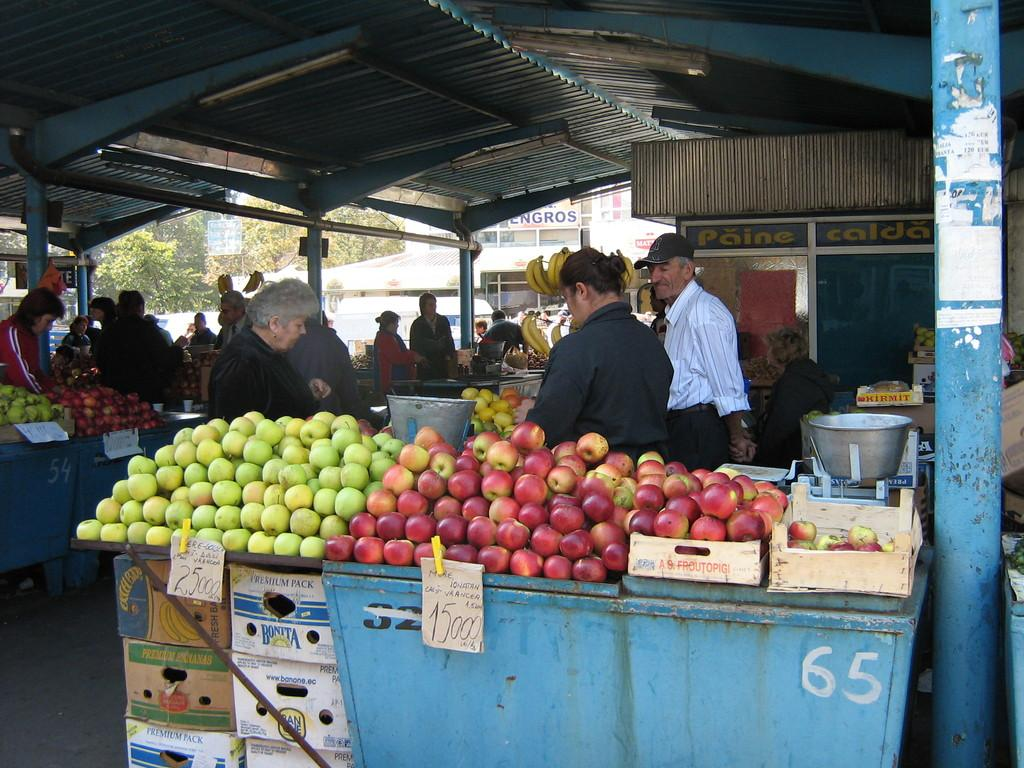What type of establishment is shown in the image? There is a fruit shop in the image. How many people can be seen inside the fruit shop? There are many people in the fruit shop. What type of fruit is visible on the desk in the fruit shop? There are apples on the desk in the fruit shop. What part of the building can be seen in the image? There is a roof visible in the image. What object is located to the right of the image? There is a pole to the right of the image. What is the title of the book that the person is reading in the image? There is no person reading a book in the image; it is a fruit shop with many people inside. 